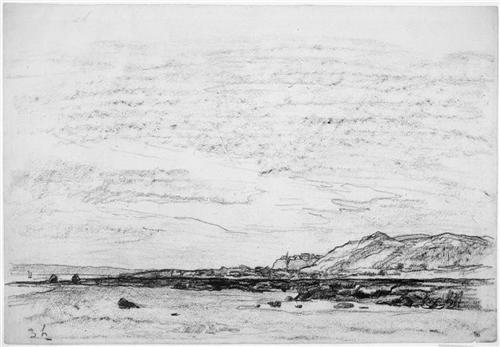How might the mood of this image change if it was in color? Adding color to this sketch would significantly alter its mood and perhaps the viewer's emotional response. Colors could infuse the scene with warmth, making it feel more inviting, or could highlight certain elements, like the sky or water, to evoke different feelings such as calmness or melancholy depending on the hues used. The starkness and simplicity of black and white, however, contributes to its timeless and tranquil atmosphere. 